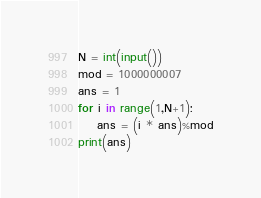Convert code to text. <code><loc_0><loc_0><loc_500><loc_500><_Python_>N = int(input())
mod = 1000000007
ans = 1
for i in range(1,N+1):
    ans = (i * ans)%mod
print(ans)</code> 